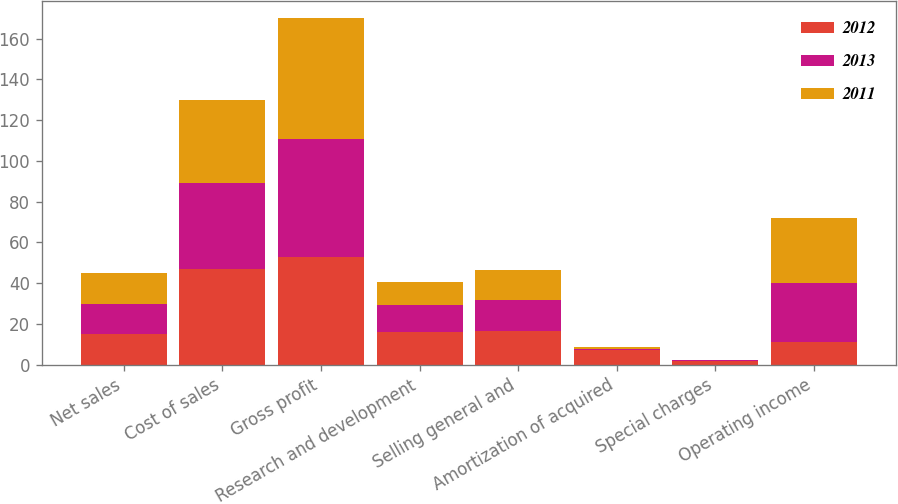Convert chart. <chart><loc_0><loc_0><loc_500><loc_500><stacked_bar_chart><ecel><fcel>Net sales<fcel>Cost of sales<fcel>Gross profit<fcel>Research and development<fcel>Selling general and<fcel>Amortization of acquired<fcel>Special charges<fcel>Operating income<nl><fcel>2012<fcel>15<fcel>47<fcel>53<fcel>16.1<fcel>16.5<fcel>7.1<fcel>2<fcel>11.3<nl><fcel>2013<fcel>15<fcel>42.2<fcel>57.8<fcel>13.2<fcel>15<fcel>0.8<fcel>0.1<fcel>28.7<nl><fcel>2011<fcel>15<fcel>40.7<fcel>59.3<fcel>11.5<fcel>15<fcel>0.8<fcel>0.1<fcel>31.9<nl></chart> 